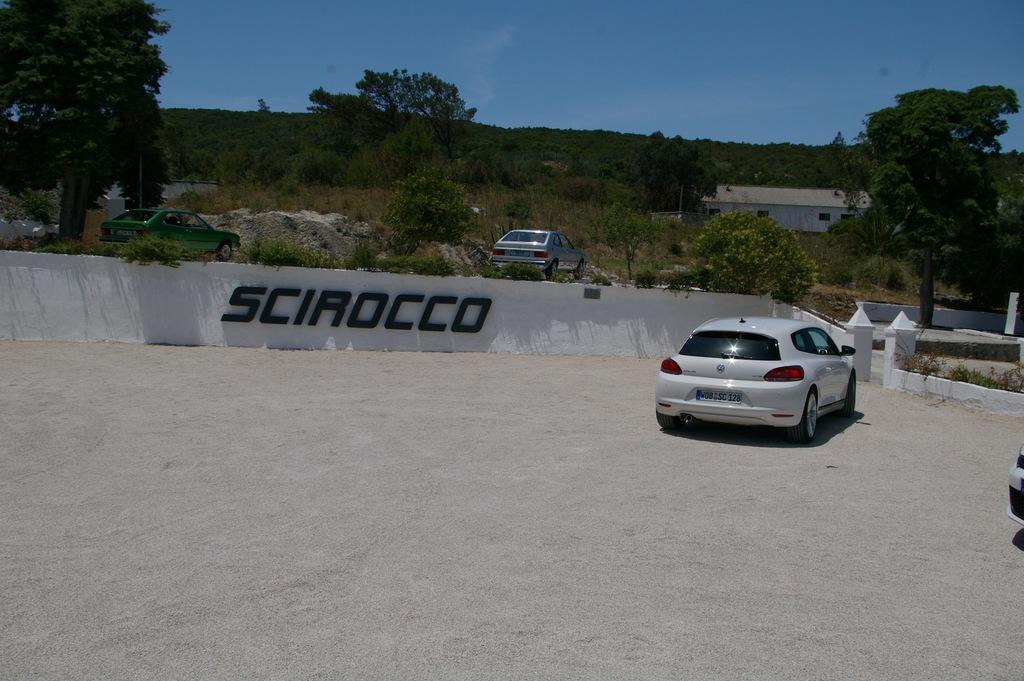In one or two sentences, can you explain what this image depicts? At the center of the image there is a label and there are cars parked on the road. At the bottom of the image there is sand. In the background there are trees and a building. At the top of the image there is sky. 